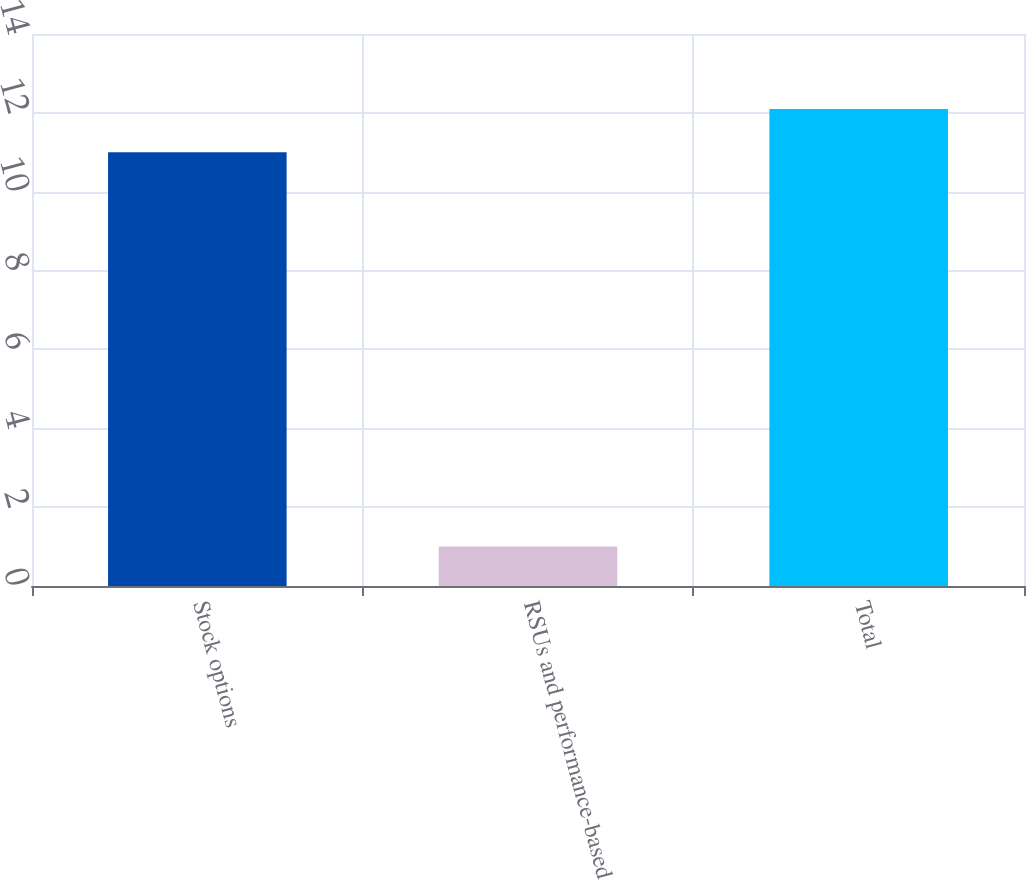Convert chart. <chart><loc_0><loc_0><loc_500><loc_500><bar_chart><fcel>Stock options<fcel>RSUs and performance-based<fcel>Total<nl><fcel>11<fcel>1<fcel>12.1<nl></chart> 